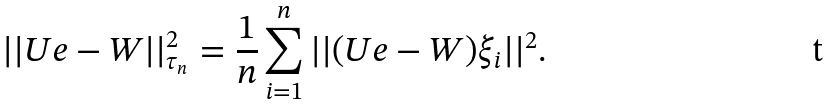<formula> <loc_0><loc_0><loc_500><loc_500>| | U e - W | | _ { \tau _ { n } } ^ { 2 } = \frac { 1 } { n } \sum _ { i = 1 } ^ { n } | | ( U e - W ) \xi _ { i } | | ^ { 2 } .</formula> 